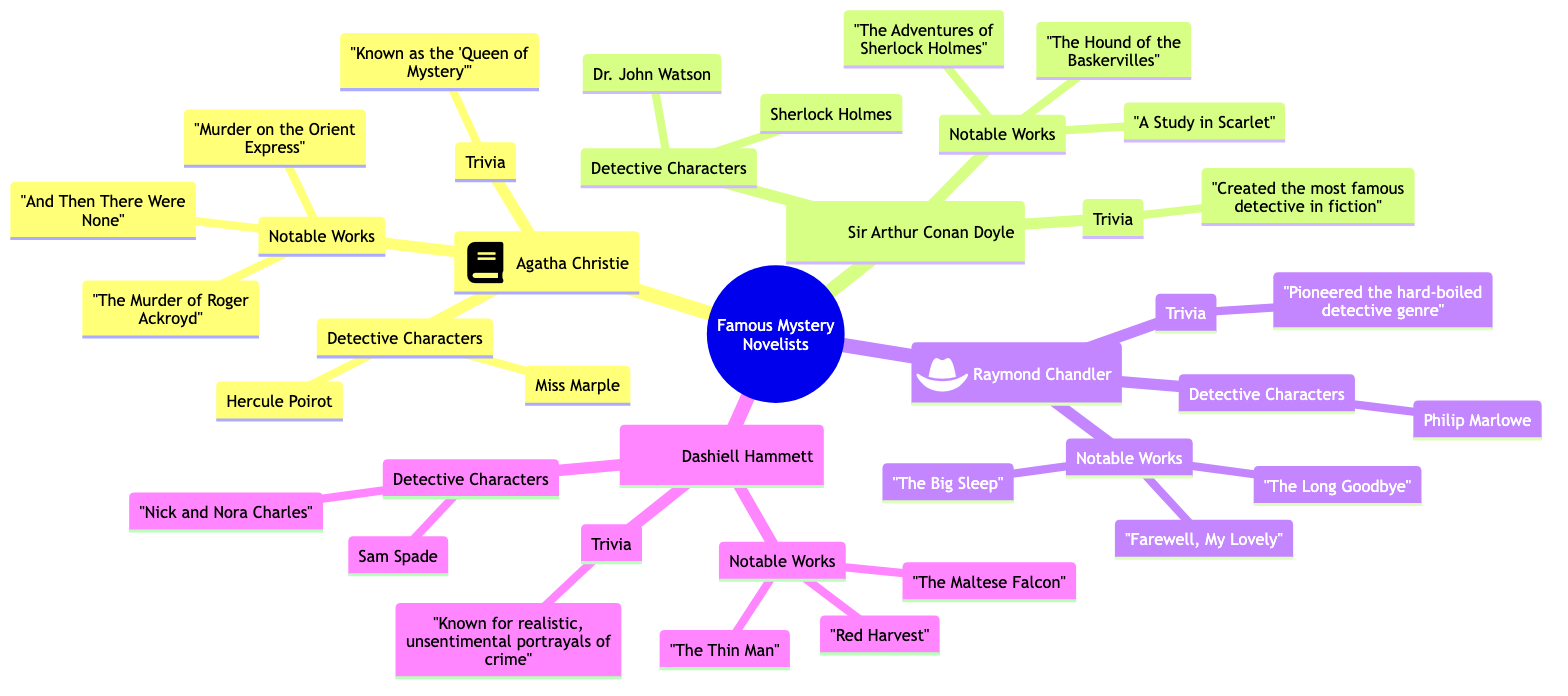What are three notable works of Agatha Christie? Agatha Christie has three notable works listed under her section: "Murder on the Orient Express," "The Murder of Roger Ackroyd," and "And Then There Were None." These titles are explicitly mentioned in the diagram.
Answer: "Murder on the Orient Express", "The Murder of Roger Ackroyd", "And Then There Were None" Who created Sherlock Holmes? The diagram indicates that Sir Arthur Conan Doyle is the author who created the character Sherlock Holmes, as he is listed under Conan Doyle's section along with his works.
Answer: Sir Arthur Conan Doyle How many detective characters are listed for Raymond Chandler? Raymond Chandler has one detective character listed under his name, which is Philip Marlowe. This is explicitly shown in the section dedicated to Chandler.
Answer: 1 What is Dashiell Hammett known for? The diagram states that Dashiell Hammett is known for "realistic, unsentimental portrayals of crime," which is presented in the trivia section under his name.
Answer: realistic, unsentimental portrayals of crime What are Agatha Christie’s detective characters? Under Agatha Christie’s section, her detective characters are listed as Hercule Poirot and Miss Marple. These names can be directly found in the corresponding part of the diagram.
Answer: Hercule Poirot, Miss Marple Which author's notable work includes "The Big Sleep"? The diagram shows that "The Big Sleep" is a notable work of Raymond Chandler, as it is specified in his section among other works.
Answer: Raymond Chandler 